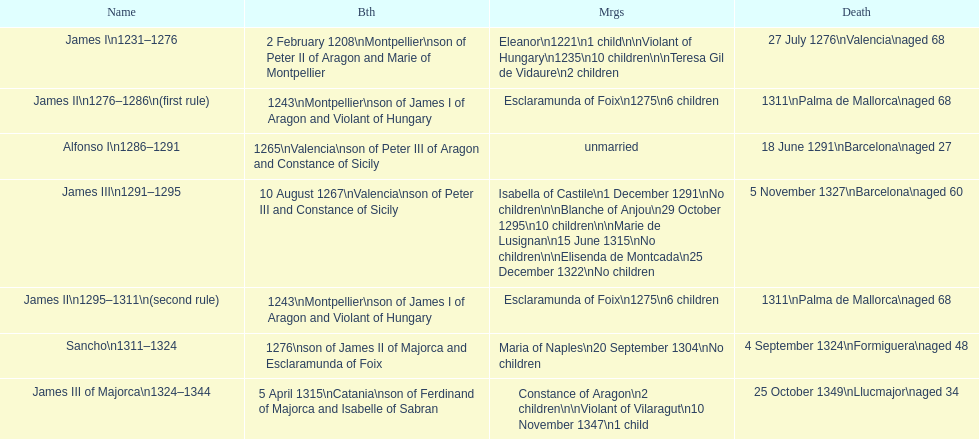Who is the first monarch on the list? James I 1231-1276. 